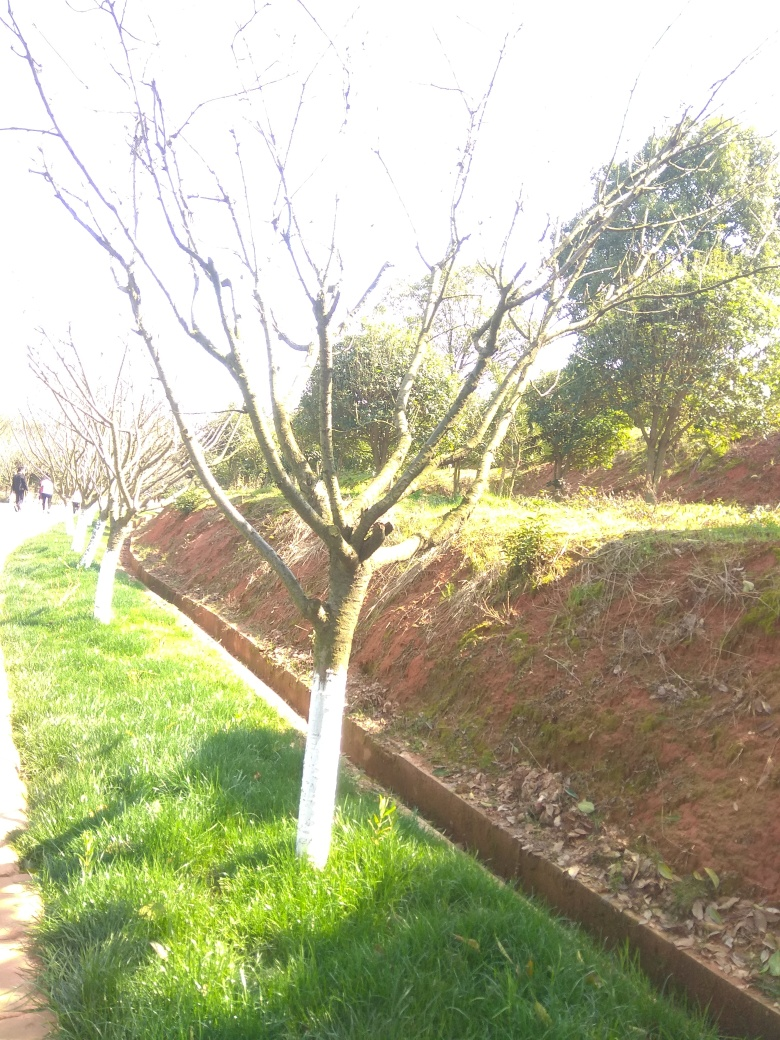Can you provide some tips on how this photo could be improved? Certainly! To improve the photo, the photographer could adjust the exposure settings to avoid overexposure, which would bring out the details of the scene. Using a lower ISO, faster shutter speed, or smaller aperture could achieve this. Additionally, choosing a different angle to include more interesting elements or to frame the subjects against a contrasting background might create a more compelling composition. 